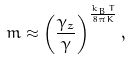Convert formula to latex. <formula><loc_0><loc_0><loc_500><loc_500>m \approx \left ( \frac { { \gamma } _ { z } } { \gamma } \right ) ^ { \frac { k _ { B } T } { 8 \pi { K } } } ,</formula> 